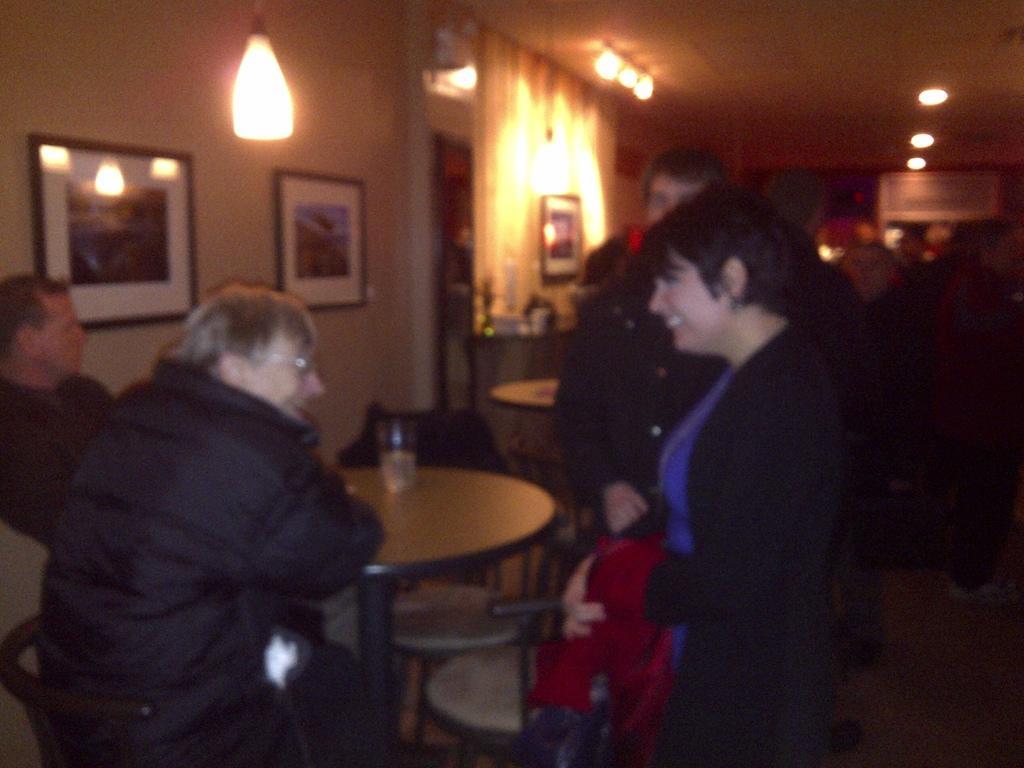How would you summarize this image in a sentence or two? The picture looks like it is clicked inside the restaurant. There are four people in the image, two are standing and two are sitting. To the right there is a woman who is wearing a black jacket and laughing. To the left there is a wall on which there are two frames and a lamp hanging near the wall. And to the top there is a roof with the lights. 